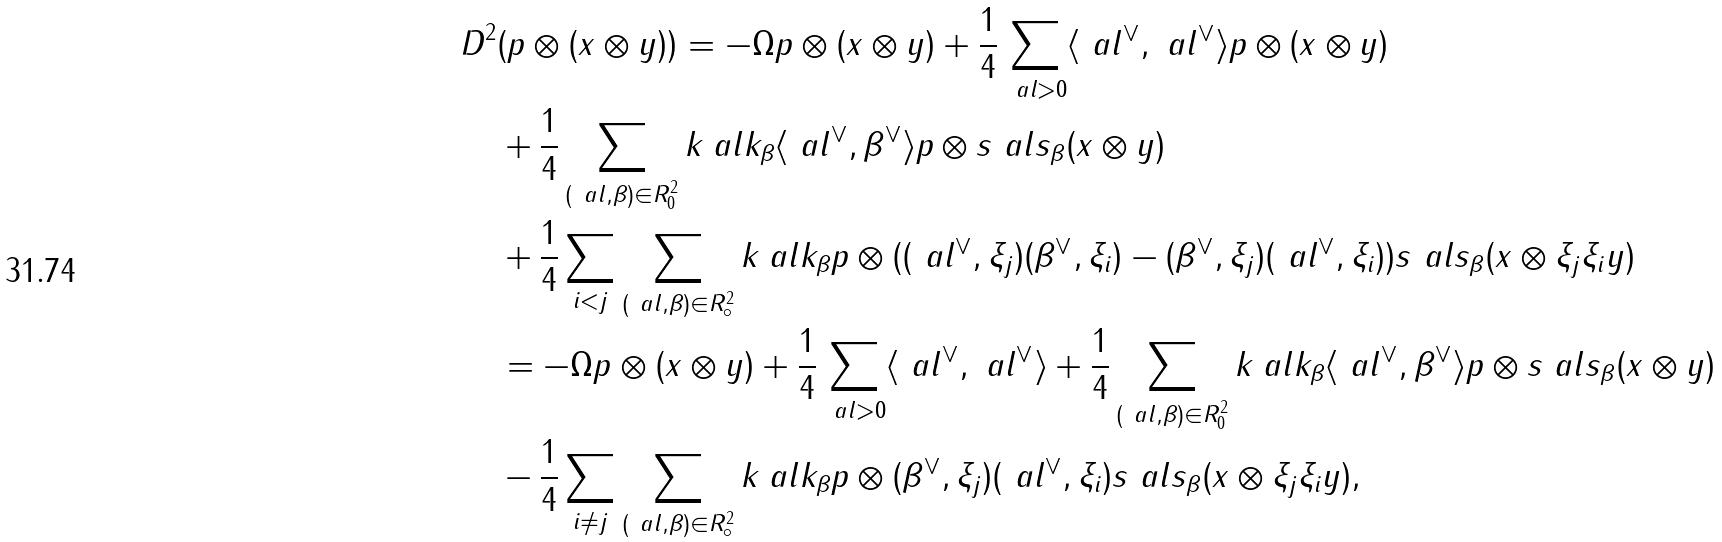<formula> <loc_0><loc_0><loc_500><loc_500>D ^ { 2 } & ( p \otimes ( x \otimes y ) ) = - \Omega p \otimes ( x \otimes y ) + \frac { 1 } { 4 } \sum _ { \ a l > 0 } \langle \ a l ^ { \vee } , \ a l ^ { \vee } \rangle p \otimes ( x \otimes y ) \\ & + \frac { 1 } { 4 } \sum _ { ( \ a l , \beta ) \in R ^ { 2 } _ { 0 } } k _ { \ } a l k _ { \beta } \langle \ a l ^ { \vee } , \beta ^ { \vee } \rangle p \otimes s _ { \ } a l s _ { \beta } ( x \otimes y ) \\ & + \frac { 1 } { 4 } \sum _ { i < j } \sum _ { ( \ a l , \beta ) \in R ^ { 2 } _ { \circ } } k _ { \ } a l k _ { \beta } p \otimes ( ( \ a l ^ { \vee } , \xi _ { j } ) ( \beta ^ { \vee } , \xi _ { i } ) - ( \beta ^ { \vee } , \xi _ { j } ) ( \ a l ^ { \vee } , \xi _ { i } ) ) s _ { \ } a l s _ { \beta } ( x \otimes \xi _ { j } \xi _ { i } y ) \\ & = - \Omega p \otimes ( x \otimes y ) + \frac { 1 } { 4 } \sum _ { \ a l > 0 } \langle \ a l ^ { \vee } , \ a l ^ { \vee } \rangle + \frac { 1 } { 4 } \sum _ { ( \ a l , \beta ) \in R ^ { 2 } _ { 0 } } k _ { \ } a l k _ { \beta } \langle \ a l ^ { \vee } , \beta ^ { \vee } \rangle p \otimes s _ { \ } a l s _ { \beta } ( x \otimes y ) \\ & - \frac { 1 } { 4 } \sum _ { i \neq j } \sum _ { ( \ a l , \beta ) \in R ^ { 2 } _ { \circ } } k _ { \ } a l k _ { \beta } p \otimes ( \beta ^ { \vee } , \xi _ { j } ) ( \ a l ^ { \vee } , \xi _ { i } ) s _ { \ } a l s _ { \beta } ( x \otimes \xi _ { j } \xi _ { i } y ) ,</formula> 